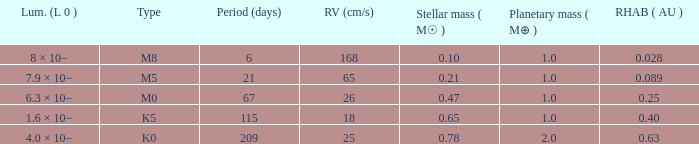What is the total stellar mass of the type m0? 0.47. 